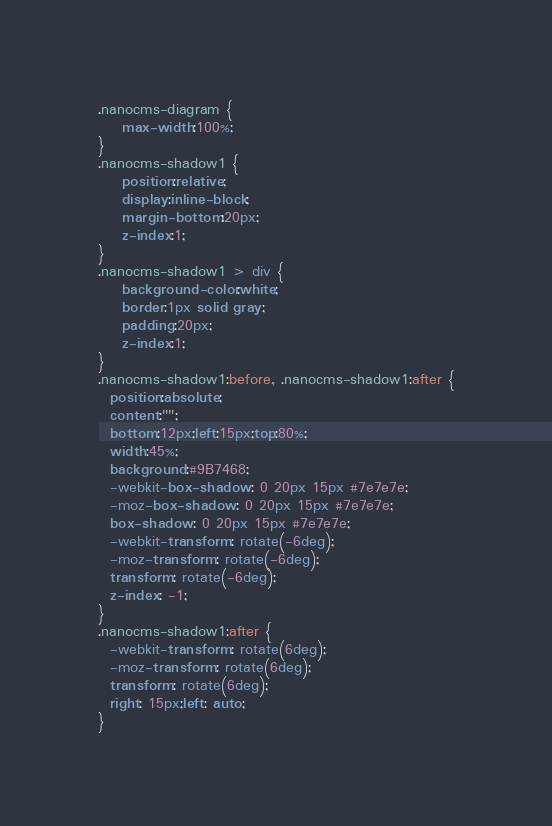<code> <loc_0><loc_0><loc_500><loc_500><_CSS_>.nanocms-diagram {
	max-width:100%;
}
.nanocms-shadow1 {
	position:relative;
	display:inline-block;
	margin-bottom:20px;
	z-index:1;
}
.nanocms-shadow1 > div {
	background-color:white;
	border:1px solid gray;
	padding:20px;
	z-index:1;
}
.nanocms-shadow1:before, .nanocms-shadow1:after {
  position:absolute;
  content:"";
  bottom:12px;left:15px;top:80%;
  width:45%;
  background:#9B7468;
  -webkit-box-shadow: 0 20px 15px #7e7e7e;
  -moz-box-shadow: 0 20px 15px #7e7e7e;
  box-shadow: 0 20px 15px #7e7e7e;
  -webkit-transform: rotate(-6deg);
  -moz-transform: rotate(-6deg);
  transform: rotate(-6deg);
  z-index: -1;
}
.nanocms-shadow1:after {
  -webkit-transform: rotate(6deg);
  -moz-transform: rotate(6deg);
  transform: rotate(6deg);
  right: 15px;left: auto;
}</code> 